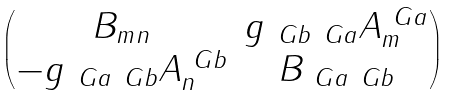Convert formula to latex. <formula><loc_0><loc_0><loc_500><loc_500>\begin{pmatrix} B _ { m n } & g _ { \ G b \ G a } A ^ { \ G a } _ { m } \\ - g _ { \ G a \ G b } A ^ { \ G b } _ { n } & B _ { \ G a \ G b } \end{pmatrix}</formula> 